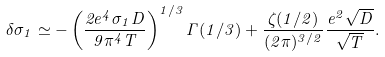<formula> <loc_0><loc_0><loc_500><loc_500>\delta \sigma _ { 1 } \simeq - \left ( \frac { 2 e ^ { 4 } \sigma _ { 1 } D } { 9 \pi ^ { 4 } T } \right ) ^ { 1 / 3 } \Gamma ( 1 / 3 ) + \frac { \zeta ( 1 / 2 ) } { ( 2 \pi ) ^ { 3 / 2 } } \frac { e ^ { 2 } \sqrt { D } } { \sqrt { T } } .</formula> 